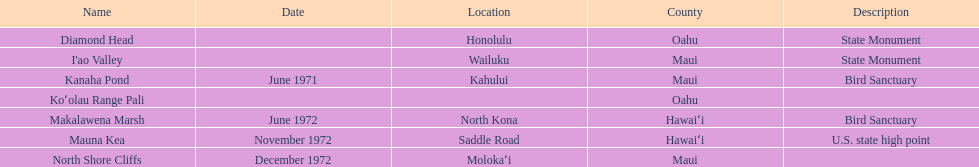How many dates are in 1972? 3. 